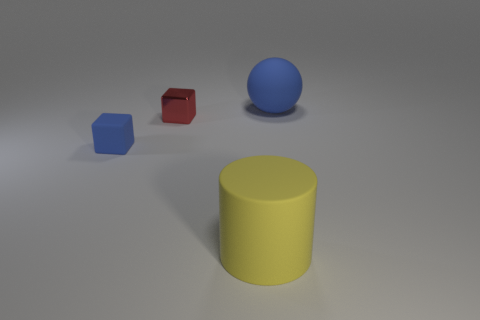Add 3 big gray rubber objects. How many objects exist? 7 Add 4 red blocks. How many red blocks are left? 5 Add 2 yellow cylinders. How many yellow cylinders exist? 3 Subtract all blue cubes. How many cubes are left? 1 Subtract 1 blue blocks. How many objects are left? 3 Subtract all balls. How many objects are left? 3 Subtract all cyan cylinders. Subtract all yellow blocks. How many cylinders are left? 1 Subtract all blue blocks. How many brown cylinders are left? 0 Subtract all matte things. Subtract all large blue matte things. How many objects are left? 0 